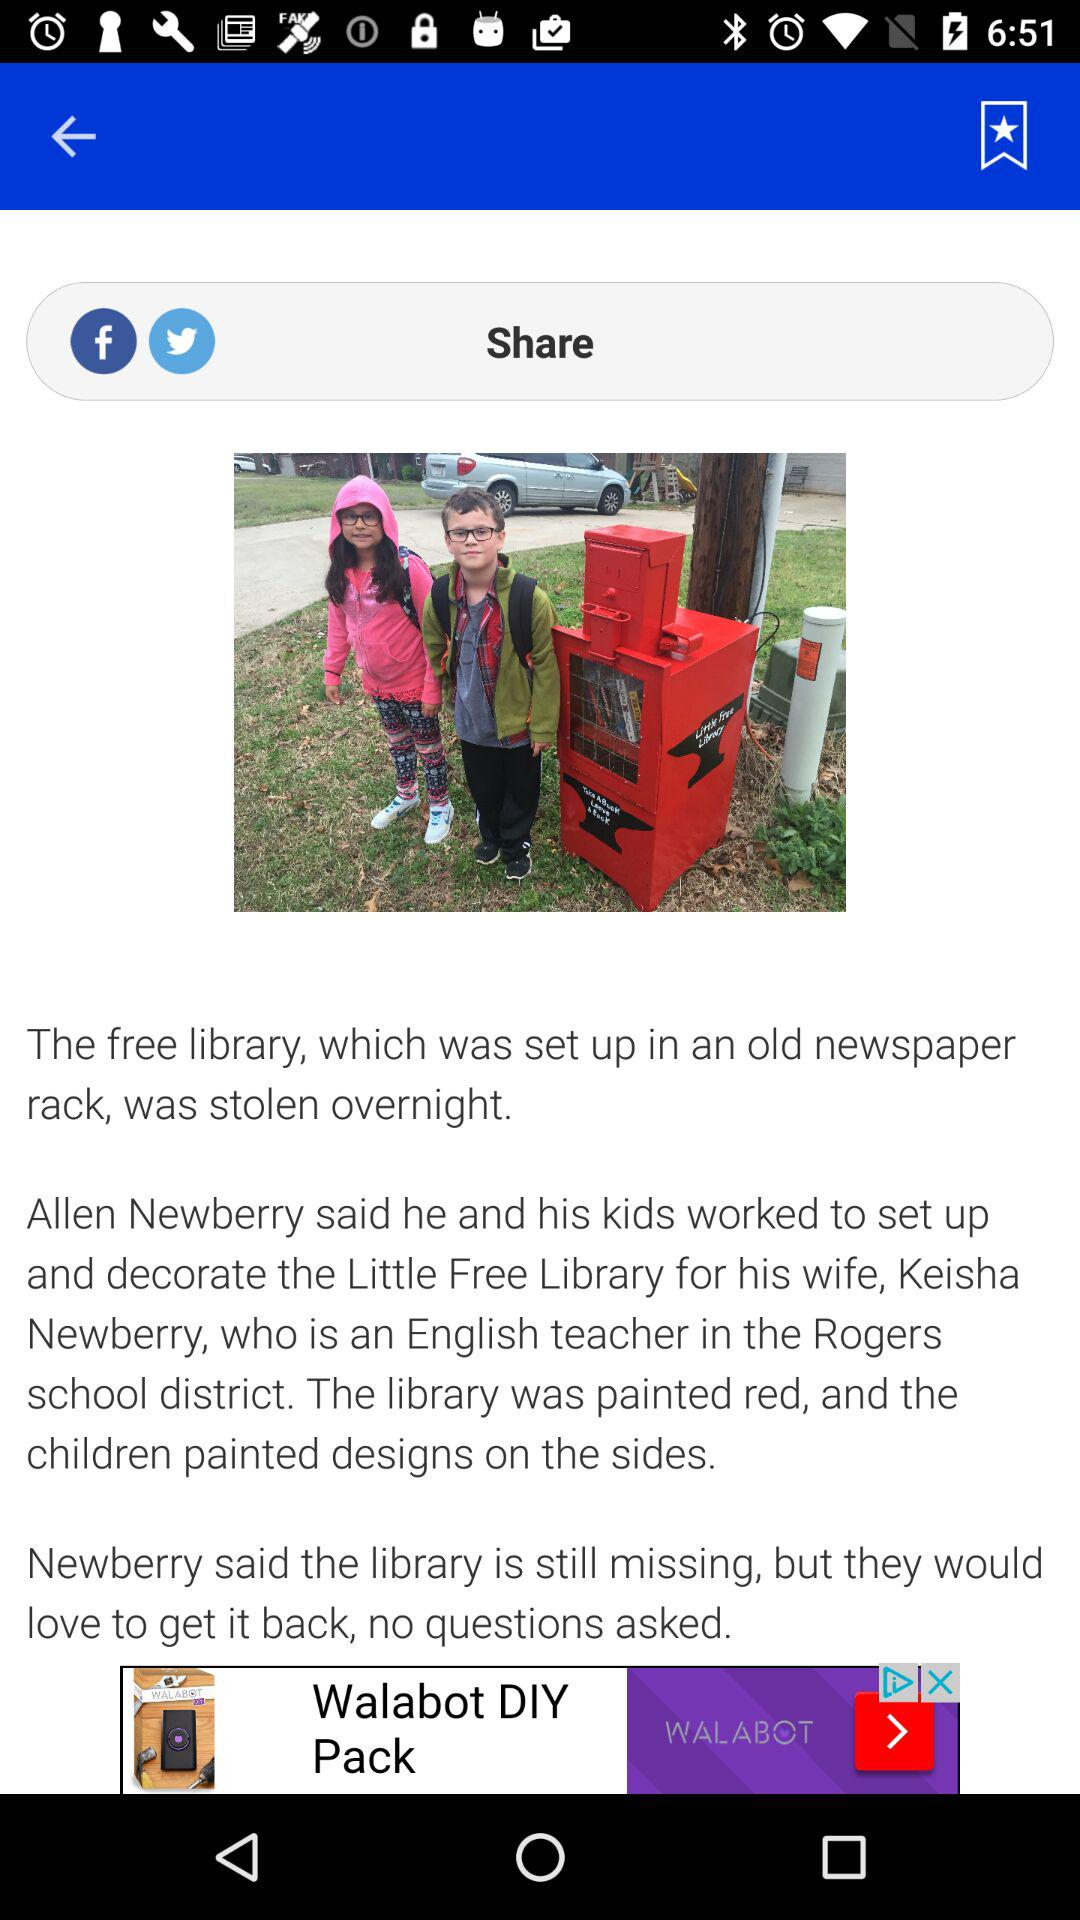What is the husband's name of Keisha Newberry? The husband's name is Allen Newberry. 